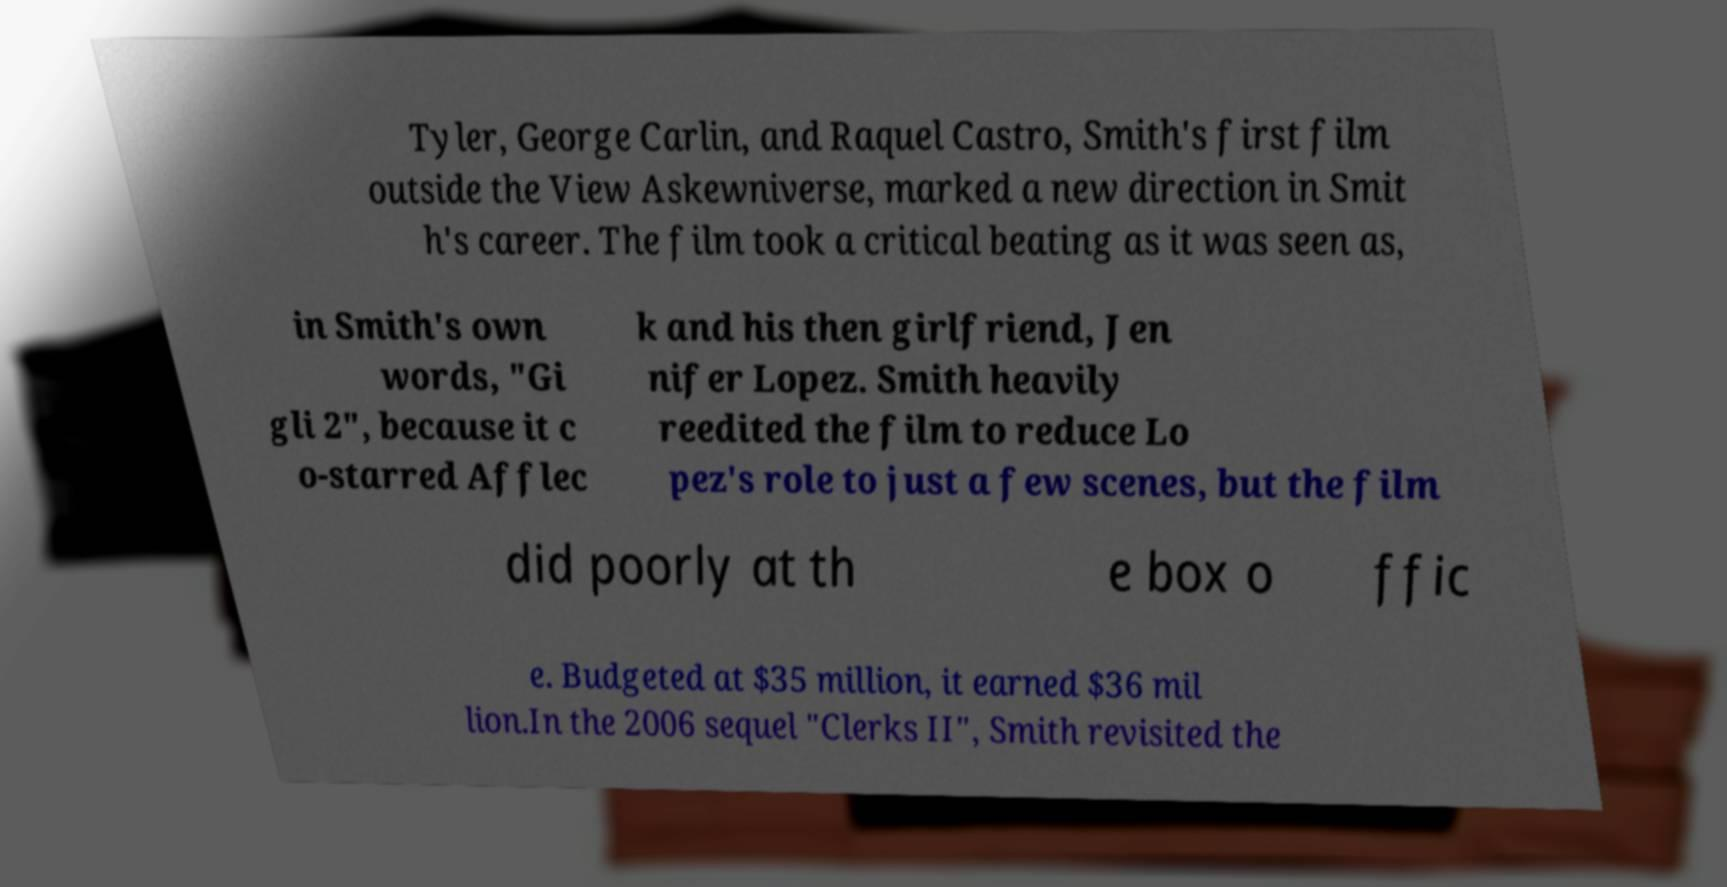Can you accurately transcribe the text from the provided image for me? Tyler, George Carlin, and Raquel Castro, Smith's first film outside the View Askewniverse, marked a new direction in Smit h's career. The film took a critical beating as it was seen as, in Smith's own words, "Gi gli 2", because it c o-starred Afflec k and his then girlfriend, Jen nifer Lopez. Smith heavily reedited the film to reduce Lo pez's role to just a few scenes, but the film did poorly at th e box o ffic e. Budgeted at $35 million, it earned $36 mil lion.In the 2006 sequel "Clerks II", Smith revisited the 